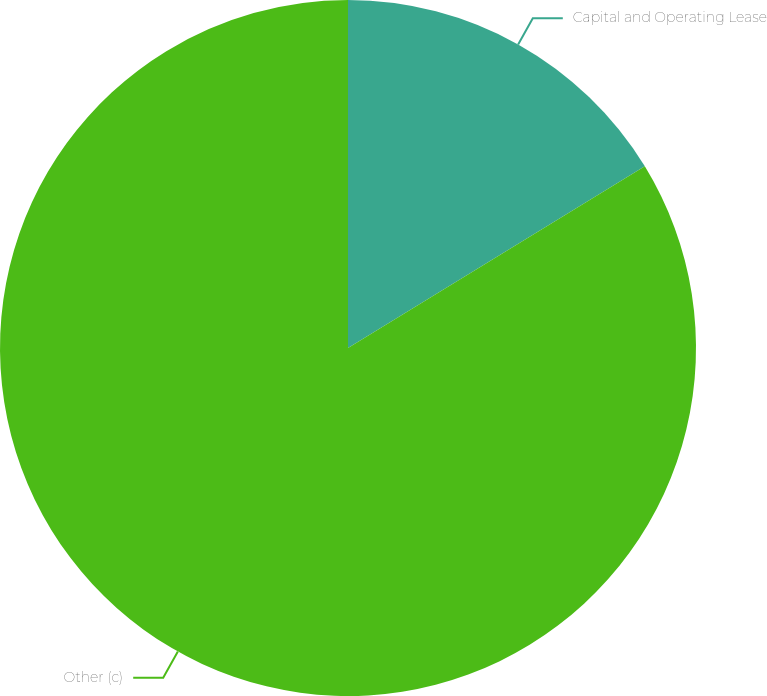Convert chart to OTSL. <chart><loc_0><loc_0><loc_500><loc_500><pie_chart><fcel>Capital and Operating Lease<fcel>Other (c)<nl><fcel>16.26%<fcel>83.74%<nl></chart> 